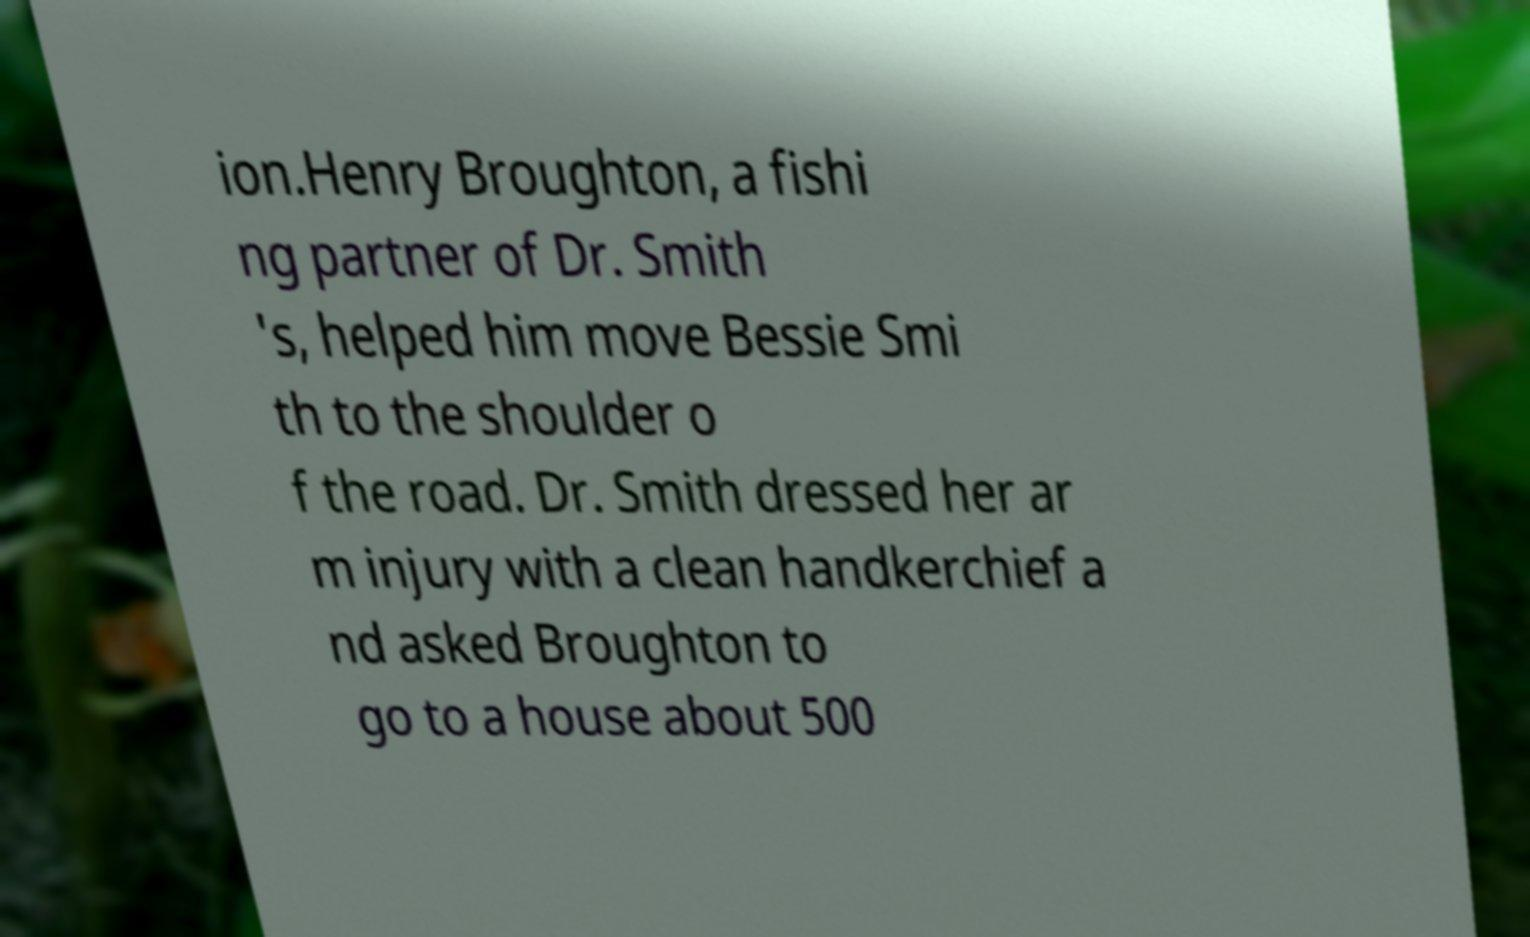Can you read and provide the text displayed in the image?This photo seems to have some interesting text. Can you extract and type it out for me? ion.Henry Broughton, a fishi ng partner of Dr. Smith 's, helped him move Bessie Smi th to the shoulder o f the road. Dr. Smith dressed her ar m injury with a clean handkerchief a nd asked Broughton to go to a house about 500 